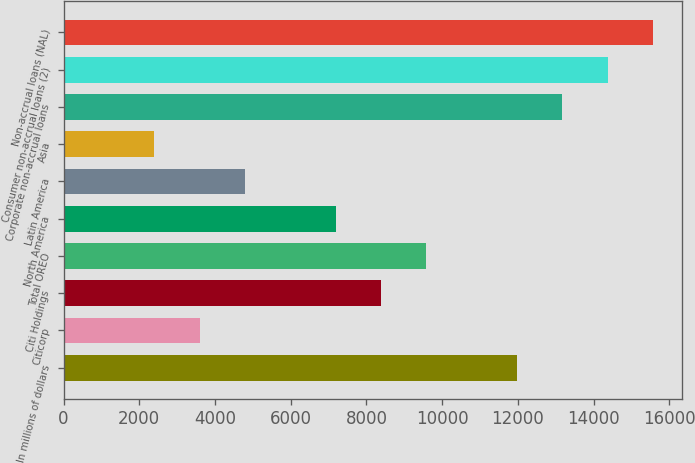Convert chart to OTSL. <chart><loc_0><loc_0><loc_500><loc_500><bar_chart><fcel>In millions of dollars<fcel>Citicorp<fcel>Citi Holdings<fcel>Total OREO<fcel>North America<fcel>Latin America<fcel>Asia<fcel>Corporate non-accrual loans<fcel>Consumer non-accrual loans (2)<fcel>Non-accrual loans (NAL)<nl><fcel>11972<fcel>3592.06<fcel>8380.62<fcel>9577.76<fcel>7183.48<fcel>4789.2<fcel>2394.92<fcel>13169.2<fcel>14366.3<fcel>15563.5<nl></chart> 